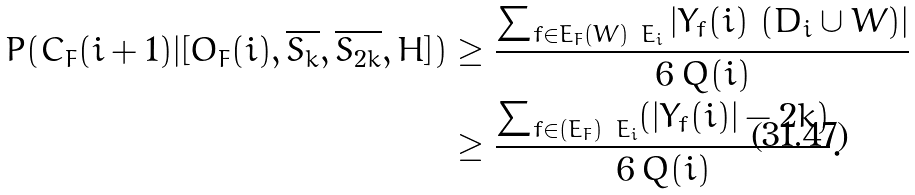Convert formula to latex. <formula><loc_0><loc_0><loc_500><loc_500>P ( C _ { F } ( i + 1 ) | [ O _ { F } ( i ) , \overline { S _ { k } } , \overline { S _ { 2 k } } , H ] ) & \geq \frac { \sum _ { f \in E _ { F } ( W ) \ E _ { i } } | Y _ { f } ( i ) \ ( D _ { i } \cup W ) | } { 6 \, Q ( i ) } \\ & \geq \frac { \sum _ { f \in ( E _ { F } ) \ E _ { i } } ( | Y _ { f } ( i ) | - 2 k ) } { 6 \, Q ( i ) } .</formula> 